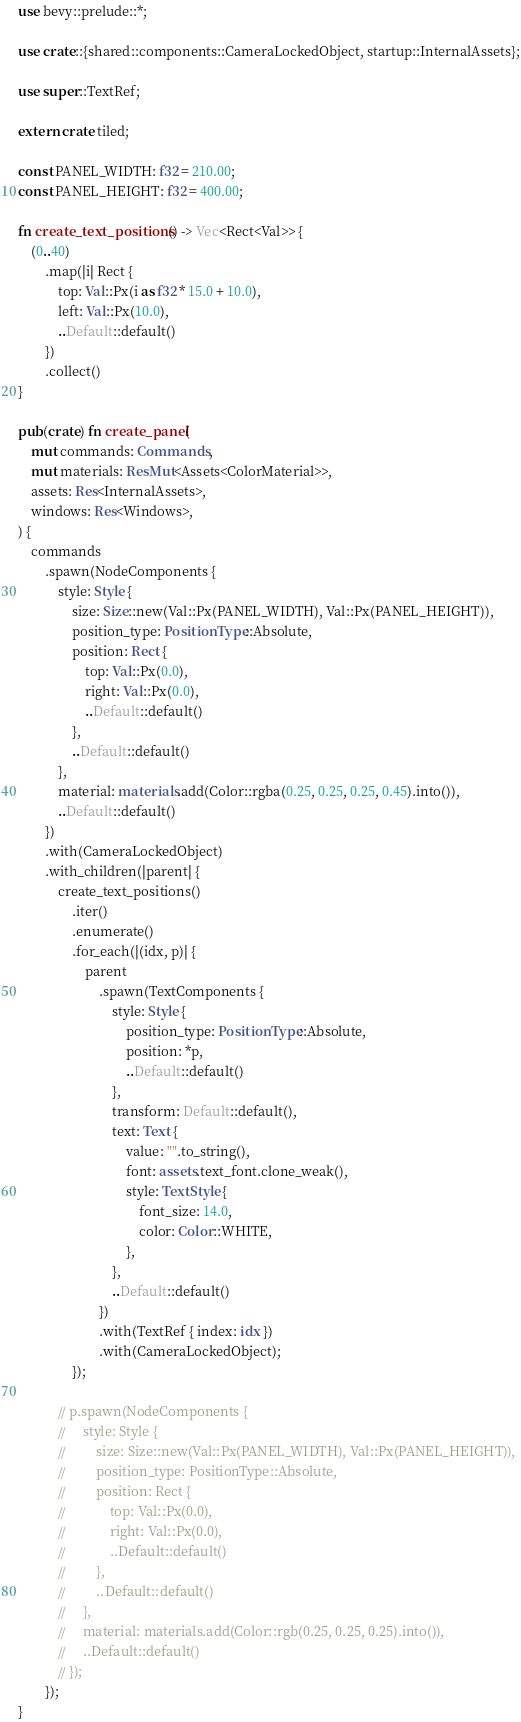Convert code to text. <code><loc_0><loc_0><loc_500><loc_500><_Rust_>use bevy::prelude::*;

use crate::{shared::components::CameraLockedObject, startup::InternalAssets};

use super::TextRef;

extern crate tiled;

const PANEL_WIDTH: f32 = 210.00;
const PANEL_HEIGHT: f32 = 400.00;

fn create_text_positions() -> Vec<Rect<Val>> {
    (0..40)
        .map(|i| Rect {
            top: Val::Px(i as f32 * 15.0 + 10.0),
            left: Val::Px(10.0),
            ..Default::default()
        })
        .collect()
}

pub(crate) fn create_panel(
    mut commands: Commands,
    mut materials: ResMut<Assets<ColorMaterial>>,
    assets: Res<InternalAssets>,
    windows: Res<Windows>,
) {
    commands
        .spawn(NodeComponents {
            style: Style {
                size: Size::new(Val::Px(PANEL_WIDTH), Val::Px(PANEL_HEIGHT)),
                position_type: PositionType::Absolute,
                position: Rect {
                    top: Val::Px(0.0),
                    right: Val::Px(0.0),
                    ..Default::default()
                },
                ..Default::default()
            },
            material: materials.add(Color::rgba(0.25, 0.25, 0.25, 0.45).into()),
            ..Default::default()
        })
        .with(CameraLockedObject)
        .with_children(|parent| {
            create_text_positions()
                .iter()
                .enumerate()
                .for_each(|(idx, p)| {
                    parent
                        .spawn(TextComponents {
                            style: Style {
                                position_type: PositionType::Absolute,
                                position: *p,
                                ..Default::default()
                            },
                            transform: Default::default(),
                            text: Text {
                                value: "".to_string(),
                                font: assets.text_font.clone_weak(),
                                style: TextStyle {
                                    font_size: 14.0,
                                    color: Color::WHITE,
                                },
                            },
                            ..Default::default()
                        })
                        .with(TextRef { index: idx })
                        .with(CameraLockedObject);
                });

            // p.spawn(NodeComponents {
            //     style: Style {
            //         size: Size::new(Val::Px(PANEL_WIDTH), Val::Px(PANEL_HEIGHT)),
            //         position_type: PositionType::Absolute,
            //         position: Rect {
            //             top: Val::Px(0.0),
            //             right: Val::Px(0.0),
            //             ..Default::default()
            //         },
            //         ..Default::default()
            //     },
            //     material: materials.add(Color::rgb(0.25, 0.25, 0.25).into()),
            //     ..Default::default()
            // });
        });
}
</code> 